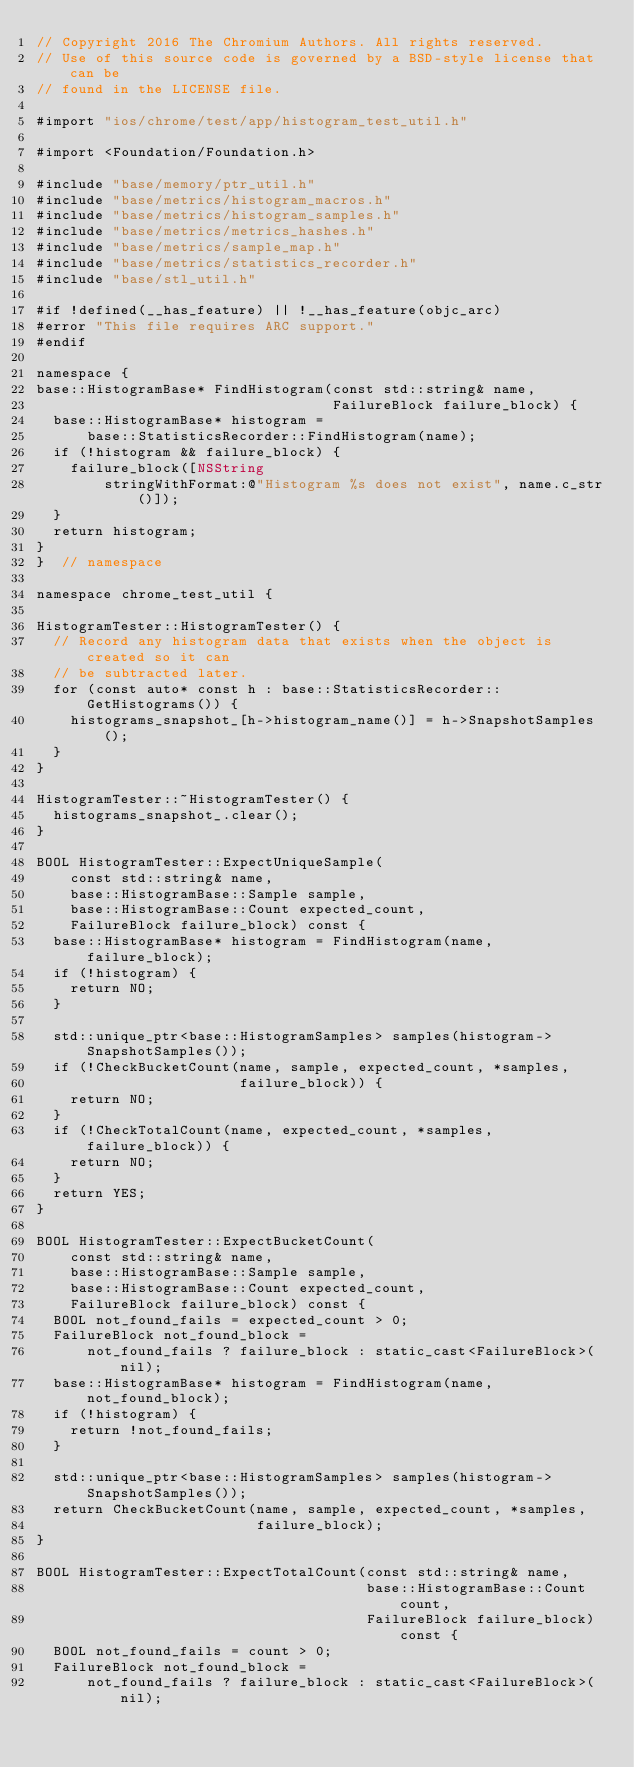<code> <loc_0><loc_0><loc_500><loc_500><_ObjectiveC_>// Copyright 2016 The Chromium Authors. All rights reserved.
// Use of this source code is governed by a BSD-style license that can be
// found in the LICENSE file.

#import "ios/chrome/test/app/histogram_test_util.h"

#import <Foundation/Foundation.h>

#include "base/memory/ptr_util.h"
#include "base/metrics/histogram_macros.h"
#include "base/metrics/histogram_samples.h"
#include "base/metrics/metrics_hashes.h"
#include "base/metrics/sample_map.h"
#include "base/metrics/statistics_recorder.h"
#include "base/stl_util.h"

#if !defined(__has_feature) || !__has_feature(objc_arc)
#error "This file requires ARC support."
#endif

namespace {
base::HistogramBase* FindHistogram(const std::string& name,
                                   FailureBlock failure_block) {
  base::HistogramBase* histogram =
      base::StatisticsRecorder::FindHistogram(name);
  if (!histogram && failure_block) {
    failure_block([NSString
        stringWithFormat:@"Histogram %s does not exist", name.c_str()]);
  }
  return histogram;
}
}  // namespace

namespace chrome_test_util {

HistogramTester::HistogramTester() {
  // Record any histogram data that exists when the object is created so it can
  // be subtracted later.
  for (const auto* const h : base::StatisticsRecorder::GetHistograms()) {
    histograms_snapshot_[h->histogram_name()] = h->SnapshotSamples();
  }
}

HistogramTester::~HistogramTester() {
  histograms_snapshot_.clear();
}

BOOL HistogramTester::ExpectUniqueSample(
    const std::string& name,
    base::HistogramBase::Sample sample,
    base::HistogramBase::Count expected_count,
    FailureBlock failure_block) const {
  base::HistogramBase* histogram = FindHistogram(name, failure_block);
  if (!histogram) {
    return NO;
  }

  std::unique_ptr<base::HistogramSamples> samples(histogram->SnapshotSamples());
  if (!CheckBucketCount(name, sample, expected_count, *samples,
                        failure_block)) {
    return NO;
  }
  if (!CheckTotalCount(name, expected_count, *samples, failure_block)) {
    return NO;
  }
  return YES;
}

BOOL HistogramTester::ExpectBucketCount(
    const std::string& name,
    base::HistogramBase::Sample sample,
    base::HistogramBase::Count expected_count,
    FailureBlock failure_block) const {
  BOOL not_found_fails = expected_count > 0;
  FailureBlock not_found_block =
      not_found_fails ? failure_block : static_cast<FailureBlock>(nil);
  base::HistogramBase* histogram = FindHistogram(name, not_found_block);
  if (!histogram) {
    return !not_found_fails;
  }

  std::unique_ptr<base::HistogramSamples> samples(histogram->SnapshotSamples());
  return CheckBucketCount(name, sample, expected_count, *samples,
                          failure_block);
}

BOOL HistogramTester::ExpectTotalCount(const std::string& name,
                                       base::HistogramBase::Count count,
                                       FailureBlock failure_block) const {
  BOOL not_found_fails = count > 0;
  FailureBlock not_found_block =
      not_found_fails ? failure_block : static_cast<FailureBlock>(nil);</code> 